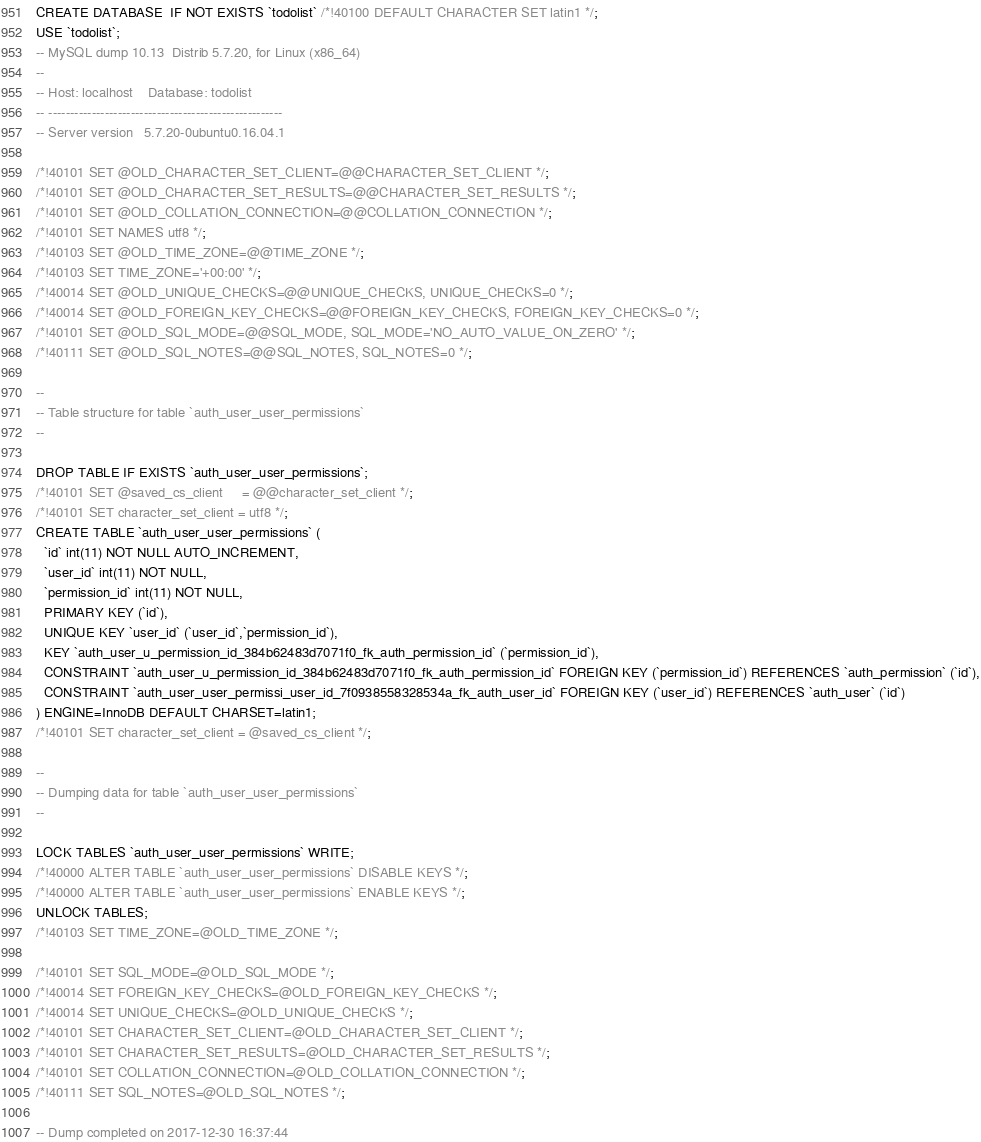Convert code to text. <code><loc_0><loc_0><loc_500><loc_500><_SQL_>CREATE DATABASE  IF NOT EXISTS `todolist` /*!40100 DEFAULT CHARACTER SET latin1 */;
USE `todolist`;
-- MySQL dump 10.13  Distrib 5.7.20, for Linux (x86_64)
--
-- Host: localhost    Database: todolist
-- ------------------------------------------------------
-- Server version	5.7.20-0ubuntu0.16.04.1

/*!40101 SET @OLD_CHARACTER_SET_CLIENT=@@CHARACTER_SET_CLIENT */;
/*!40101 SET @OLD_CHARACTER_SET_RESULTS=@@CHARACTER_SET_RESULTS */;
/*!40101 SET @OLD_COLLATION_CONNECTION=@@COLLATION_CONNECTION */;
/*!40101 SET NAMES utf8 */;
/*!40103 SET @OLD_TIME_ZONE=@@TIME_ZONE */;
/*!40103 SET TIME_ZONE='+00:00' */;
/*!40014 SET @OLD_UNIQUE_CHECKS=@@UNIQUE_CHECKS, UNIQUE_CHECKS=0 */;
/*!40014 SET @OLD_FOREIGN_KEY_CHECKS=@@FOREIGN_KEY_CHECKS, FOREIGN_KEY_CHECKS=0 */;
/*!40101 SET @OLD_SQL_MODE=@@SQL_MODE, SQL_MODE='NO_AUTO_VALUE_ON_ZERO' */;
/*!40111 SET @OLD_SQL_NOTES=@@SQL_NOTES, SQL_NOTES=0 */;

--
-- Table structure for table `auth_user_user_permissions`
--

DROP TABLE IF EXISTS `auth_user_user_permissions`;
/*!40101 SET @saved_cs_client     = @@character_set_client */;
/*!40101 SET character_set_client = utf8 */;
CREATE TABLE `auth_user_user_permissions` (
  `id` int(11) NOT NULL AUTO_INCREMENT,
  `user_id` int(11) NOT NULL,
  `permission_id` int(11) NOT NULL,
  PRIMARY KEY (`id`),
  UNIQUE KEY `user_id` (`user_id`,`permission_id`),
  KEY `auth_user_u_permission_id_384b62483d7071f0_fk_auth_permission_id` (`permission_id`),
  CONSTRAINT `auth_user_u_permission_id_384b62483d7071f0_fk_auth_permission_id` FOREIGN KEY (`permission_id`) REFERENCES `auth_permission` (`id`),
  CONSTRAINT `auth_user_user_permissi_user_id_7f0938558328534a_fk_auth_user_id` FOREIGN KEY (`user_id`) REFERENCES `auth_user` (`id`)
) ENGINE=InnoDB DEFAULT CHARSET=latin1;
/*!40101 SET character_set_client = @saved_cs_client */;

--
-- Dumping data for table `auth_user_user_permissions`
--

LOCK TABLES `auth_user_user_permissions` WRITE;
/*!40000 ALTER TABLE `auth_user_user_permissions` DISABLE KEYS */;
/*!40000 ALTER TABLE `auth_user_user_permissions` ENABLE KEYS */;
UNLOCK TABLES;
/*!40103 SET TIME_ZONE=@OLD_TIME_ZONE */;

/*!40101 SET SQL_MODE=@OLD_SQL_MODE */;
/*!40014 SET FOREIGN_KEY_CHECKS=@OLD_FOREIGN_KEY_CHECKS */;
/*!40014 SET UNIQUE_CHECKS=@OLD_UNIQUE_CHECKS */;
/*!40101 SET CHARACTER_SET_CLIENT=@OLD_CHARACTER_SET_CLIENT */;
/*!40101 SET CHARACTER_SET_RESULTS=@OLD_CHARACTER_SET_RESULTS */;
/*!40101 SET COLLATION_CONNECTION=@OLD_COLLATION_CONNECTION */;
/*!40111 SET SQL_NOTES=@OLD_SQL_NOTES */;

-- Dump completed on 2017-12-30 16:37:44
</code> 